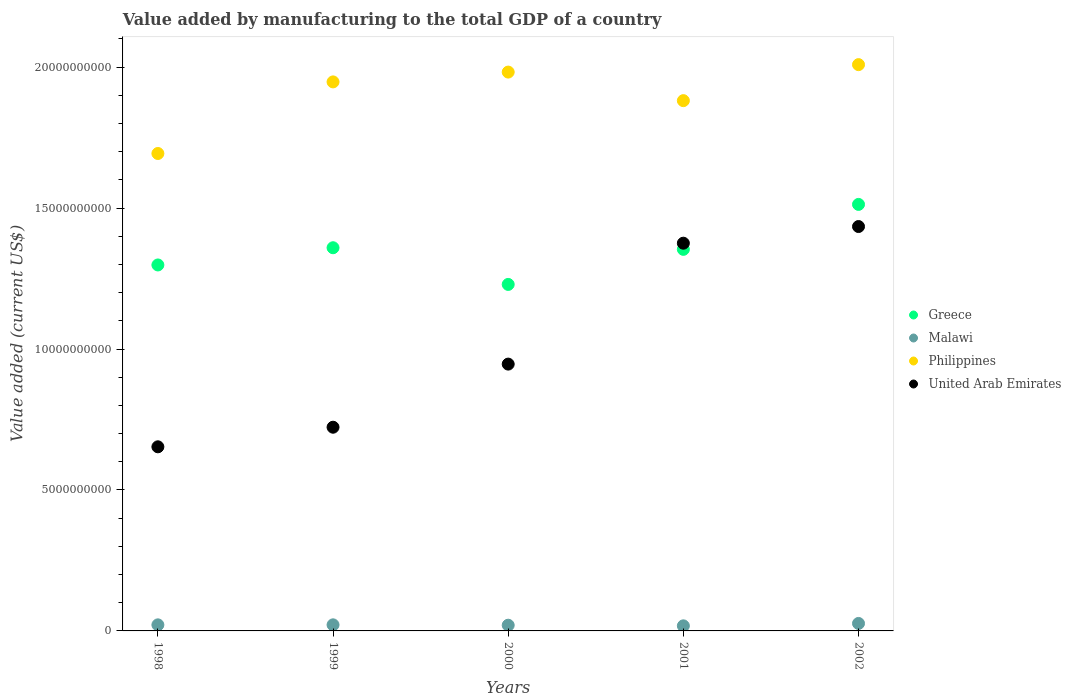How many different coloured dotlines are there?
Offer a terse response. 4. Is the number of dotlines equal to the number of legend labels?
Keep it short and to the point. Yes. What is the value added by manufacturing to the total GDP in United Arab Emirates in 1999?
Your answer should be compact. 7.23e+09. Across all years, what is the maximum value added by manufacturing to the total GDP in Malawi?
Your response must be concise. 2.65e+08. Across all years, what is the minimum value added by manufacturing to the total GDP in Greece?
Give a very brief answer. 1.23e+1. In which year was the value added by manufacturing to the total GDP in Philippines maximum?
Keep it short and to the point. 2002. What is the total value added by manufacturing to the total GDP in United Arab Emirates in the graph?
Offer a very short reply. 5.13e+1. What is the difference between the value added by manufacturing to the total GDP in Malawi in 2000 and that in 2002?
Keep it short and to the point. -6.27e+07. What is the difference between the value added by manufacturing to the total GDP in Philippines in 2002 and the value added by manufacturing to the total GDP in Malawi in 2001?
Offer a very short reply. 1.99e+1. What is the average value added by manufacturing to the total GDP in Malawi per year?
Your answer should be very brief. 2.16e+08. In the year 2001, what is the difference between the value added by manufacturing to the total GDP in United Arab Emirates and value added by manufacturing to the total GDP in Greece?
Give a very brief answer. 2.18e+08. In how many years, is the value added by manufacturing to the total GDP in United Arab Emirates greater than 14000000000 US$?
Provide a short and direct response. 1. What is the ratio of the value added by manufacturing to the total GDP in United Arab Emirates in 1998 to that in 1999?
Your response must be concise. 0.9. Is the value added by manufacturing to the total GDP in United Arab Emirates in 1999 less than that in 2001?
Your answer should be very brief. Yes. Is the difference between the value added by manufacturing to the total GDP in United Arab Emirates in 2001 and 2002 greater than the difference between the value added by manufacturing to the total GDP in Greece in 2001 and 2002?
Provide a short and direct response. Yes. What is the difference between the highest and the second highest value added by manufacturing to the total GDP in United Arab Emirates?
Ensure brevity in your answer.  5.91e+08. What is the difference between the highest and the lowest value added by manufacturing to the total GDP in Greece?
Keep it short and to the point. 2.84e+09. Is the sum of the value added by manufacturing to the total GDP in Greece in 1998 and 1999 greater than the maximum value added by manufacturing to the total GDP in United Arab Emirates across all years?
Ensure brevity in your answer.  Yes. Is it the case that in every year, the sum of the value added by manufacturing to the total GDP in Philippines and value added by manufacturing to the total GDP in United Arab Emirates  is greater than the sum of value added by manufacturing to the total GDP in Greece and value added by manufacturing to the total GDP in Malawi?
Provide a succinct answer. No. Is it the case that in every year, the sum of the value added by manufacturing to the total GDP in United Arab Emirates and value added by manufacturing to the total GDP in Malawi  is greater than the value added by manufacturing to the total GDP in Greece?
Provide a short and direct response. No. Is the value added by manufacturing to the total GDP in Malawi strictly greater than the value added by manufacturing to the total GDP in Philippines over the years?
Ensure brevity in your answer.  No. Is the value added by manufacturing to the total GDP in Greece strictly less than the value added by manufacturing to the total GDP in United Arab Emirates over the years?
Provide a succinct answer. No. How many years are there in the graph?
Offer a terse response. 5. Are the values on the major ticks of Y-axis written in scientific E-notation?
Provide a succinct answer. No. Does the graph contain any zero values?
Your answer should be very brief. No. Where does the legend appear in the graph?
Your response must be concise. Center right. How many legend labels are there?
Your response must be concise. 4. How are the legend labels stacked?
Your answer should be compact. Vertical. What is the title of the graph?
Ensure brevity in your answer.  Value added by manufacturing to the total GDP of a country. Does "Tuvalu" appear as one of the legend labels in the graph?
Offer a very short reply. No. What is the label or title of the Y-axis?
Provide a succinct answer. Value added (current US$). What is the Value added (current US$) in Greece in 1998?
Offer a very short reply. 1.30e+1. What is the Value added (current US$) of Malawi in 1998?
Make the answer very short. 2.16e+08. What is the Value added (current US$) in Philippines in 1998?
Keep it short and to the point. 1.69e+1. What is the Value added (current US$) in United Arab Emirates in 1998?
Offer a very short reply. 6.53e+09. What is the Value added (current US$) of Greece in 1999?
Your answer should be compact. 1.36e+1. What is the Value added (current US$) of Malawi in 1999?
Your answer should be compact. 2.16e+08. What is the Value added (current US$) in Philippines in 1999?
Your answer should be very brief. 1.95e+1. What is the Value added (current US$) of United Arab Emirates in 1999?
Provide a short and direct response. 7.23e+09. What is the Value added (current US$) in Greece in 2000?
Make the answer very short. 1.23e+1. What is the Value added (current US$) of Malawi in 2000?
Ensure brevity in your answer.  2.03e+08. What is the Value added (current US$) in Philippines in 2000?
Ensure brevity in your answer.  1.98e+1. What is the Value added (current US$) of United Arab Emirates in 2000?
Your answer should be very brief. 9.47e+09. What is the Value added (current US$) of Greece in 2001?
Provide a short and direct response. 1.35e+1. What is the Value added (current US$) of Malawi in 2001?
Offer a terse response. 1.80e+08. What is the Value added (current US$) in Philippines in 2001?
Keep it short and to the point. 1.88e+1. What is the Value added (current US$) in United Arab Emirates in 2001?
Your response must be concise. 1.38e+1. What is the Value added (current US$) of Greece in 2002?
Keep it short and to the point. 1.51e+1. What is the Value added (current US$) in Malawi in 2002?
Your answer should be compact. 2.65e+08. What is the Value added (current US$) of Philippines in 2002?
Give a very brief answer. 2.01e+1. What is the Value added (current US$) of United Arab Emirates in 2002?
Your answer should be compact. 1.43e+1. Across all years, what is the maximum Value added (current US$) of Greece?
Give a very brief answer. 1.51e+1. Across all years, what is the maximum Value added (current US$) of Malawi?
Keep it short and to the point. 2.65e+08. Across all years, what is the maximum Value added (current US$) in Philippines?
Give a very brief answer. 2.01e+1. Across all years, what is the maximum Value added (current US$) of United Arab Emirates?
Your answer should be compact. 1.43e+1. Across all years, what is the minimum Value added (current US$) in Greece?
Your answer should be compact. 1.23e+1. Across all years, what is the minimum Value added (current US$) in Malawi?
Your answer should be very brief. 1.80e+08. Across all years, what is the minimum Value added (current US$) of Philippines?
Provide a succinct answer. 1.69e+1. Across all years, what is the minimum Value added (current US$) of United Arab Emirates?
Give a very brief answer. 6.53e+09. What is the total Value added (current US$) of Greece in the graph?
Give a very brief answer. 6.75e+1. What is the total Value added (current US$) of Malawi in the graph?
Offer a very short reply. 1.08e+09. What is the total Value added (current US$) in Philippines in the graph?
Give a very brief answer. 9.51e+1. What is the total Value added (current US$) of United Arab Emirates in the graph?
Your answer should be very brief. 5.13e+1. What is the difference between the Value added (current US$) in Greece in 1998 and that in 1999?
Make the answer very short. -6.11e+08. What is the difference between the Value added (current US$) of Malawi in 1998 and that in 1999?
Your response must be concise. -5.31e+05. What is the difference between the Value added (current US$) in Philippines in 1998 and that in 1999?
Provide a short and direct response. -2.54e+09. What is the difference between the Value added (current US$) in United Arab Emirates in 1998 and that in 1999?
Provide a succinct answer. -6.95e+08. What is the difference between the Value added (current US$) in Greece in 1998 and that in 2000?
Provide a short and direct response. 6.91e+08. What is the difference between the Value added (current US$) in Malawi in 1998 and that in 2000?
Provide a short and direct response. 1.30e+07. What is the difference between the Value added (current US$) of Philippines in 1998 and that in 2000?
Your response must be concise. -2.89e+09. What is the difference between the Value added (current US$) of United Arab Emirates in 1998 and that in 2000?
Offer a very short reply. -2.93e+09. What is the difference between the Value added (current US$) in Greece in 1998 and that in 2001?
Make the answer very short. -5.54e+08. What is the difference between the Value added (current US$) of Malawi in 1998 and that in 2001?
Offer a very short reply. 3.54e+07. What is the difference between the Value added (current US$) in Philippines in 1998 and that in 2001?
Your answer should be very brief. -1.87e+09. What is the difference between the Value added (current US$) in United Arab Emirates in 1998 and that in 2001?
Keep it short and to the point. -7.22e+09. What is the difference between the Value added (current US$) of Greece in 1998 and that in 2002?
Keep it short and to the point. -2.15e+09. What is the difference between the Value added (current US$) in Malawi in 1998 and that in 2002?
Your answer should be compact. -4.97e+07. What is the difference between the Value added (current US$) in Philippines in 1998 and that in 2002?
Your response must be concise. -3.15e+09. What is the difference between the Value added (current US$) of United Arab Emirates in 1998 and that in 2002?
Make the answer very short. -7.81e+09. What is the difference between the Value added (current US$) in Greece in 1999 and that in 2000?
Your response must be concise. 1.30e+09. What is the difference between the Value added (current US$) of Malawi in 1999 and that in 2000?
Keep it short and to the point. 1.35e+07. What is the difference between the Value added (current US$) of Philippines in 1999 and that in 2000?
Provide a succinct answer. -3.48e+08. What is the difference between the Value added (current US$) in United Arab Emirates in 1999 and that in 2000?
Your response must be concise. -2.24e+09. What is the difference between the Value added (current US$) in Greece in 1999 and that in 2001?
Ensure brevity in your answer.  5.73e+07. What is the difference between the Value added (current US$) in Malawi in 1999 and that in 2001?
Your answer should be very brief. 3.59e+07. What is the difference between the Value added (current US$) of Philippines in 1999 and that in 2001?
Provide a short and direct response. 6.65e+08. What is the difference between the Value added (current US$) in United Arab Emirates in 1999 and that in 2001?
Your answer should be very brief. -6.53e+09. What is the difference between the Value added (current US$) in Greece in 1999 and that in 2002?
Your response must be concise. -1.54e+09. What is the difference between the Value added (current US$) of Malawi in 1999 and that in 2002?
Ensure brevity in your answer.  -4.92e+07. What is the difference between the Value added (current US$) in Philippines in 1999 and that in 2002?
Offer a terse response. -6.12e+08. What is the difference between the Value added (current US$) of United Arab Emirates in 1999 and that in 2002?
Offer a terse response. -7.12e+09. What is the difference between the Value added (current US$) in Greece in 2000 and that in 2001?
Offer a very short reply. -1.24e+09. What is the difference between the Value added (current US$) in Malawi in 2000 and that in 2001?
Offer a very short reply. 2.24e+07. What is the difference between the Value added (current US$) of Philippines in 2000 and that in 2001?
Provide a short and direct response. 1.01e+09. What is the difference between the Value added (current US$) in United Arab Emirates in 2000 and that in 2001?
Offer a very short reply. -4.29e+09. What is the difference between the Value added (current US$) in Greece in 2000 and that in 2002?
Provide a succinct answer. -2.84e+09. What is the difference between the Value added (current US$) in Malawi in 2000 and that in 2002?
Give a very brief answer. -6.27e+07. What is the difference between the Value added (current US$) in Philippines in 2000 and that in 2002?
Ensure brevity in your answer.  -2.64e+08. What is the difference between the Value added (current US$) in United Arab Emirates in 2000 and that in 2002?
Provide a short and direct response. -4.88e+09. What is the difference between the Value added (current US$) of Greece in 2001 and that in 2002?
Offer a terse response. -1.59e+09. What is the difference between the Value added (current US$) in Malawi in 2001 and that in 2002?
Provide a short and direct response. -8.51e+07. What is the difference between the Value added (current US$) of Philippines in 2001 and that in 2002?
Keep it short and to the point. -1.28e+09. What is the difference between the Value added (current US$) in United Arab Emirates in 2001 and that in 2002?
Give a very brief answer. -5.91e+08. What is the difference between the Value added (current US$) of Greece in 1998 and the Value added (current US$) of Malawi in 1999?
Your response must be concise. 1.28e+1. What is the difference between the Value added (current US$) of Greece in 1998 and the Value added (current US$) of Philippines in 1999?
Offer a very short reply. -6.49e+09. What is the difference between the Value added (current US$) in Greece in 1998 and the Value added (current US$) in United Arab Emirates in 1999?
Keep it short and to the point. 5.76e+09. What is the difference between the Value added (current US$) of Malawi in 1998 and the Value added (current US$) of Philippines in 1999?
Make the answer very short. -1.93e+1. What is the difference between the Value added (current US$) in Malawi in 1998 and the Value added (current US$) in United Arab Emirates in 1999?
Your response must be concise. -7.01e+09. What is the difference between the Value added (current US$) in Philippines in 1998 and the Value added (current US$) in United Arab Emirates in 1999?
Offer a very short reply. 9.71e+09. What is the difference between the Value added (current US$) in Greece in 1998 and the Value added (current US$) in Malawi in 2000?
Provide a short and direct response. 1.28e+1. What is the difference between the Value added (current US$) in Greece in 1998 and the Value added (current US$) in Philippines in 2000?
Keep it short and to the point. -6.84e+09. What is the difference between the Value added (current US$) of Greece in 1998 and the Value added (current US$) of United Arab Emirates in 2000?
Keep it short and to the point. 3.52e+09. What is the difference between the Value added (current US$) of Malawi in 1998 and the Value added (current US$) of Philippines in 2000?
Offer a terse response. -1.96e+1. What is the difference between the Value added (current US$) in Malawi in 1998 and the Value added (current US$) in United Arab Emirates in 2000?
Your answer should be compact. -9.25e+09. What is the difference between the Value added (current US$) of Philippines in 1998 and the Value added (current US$) of United Arab Emirates in 2000?
Ensure brevity in your answer.  7.47e+09. What is the difference between the Value added (current US$) of Greece in 1998 and the Value added (current US$) of Malawi in 2001?
Provide a succinct answer. 1.28e+1. What is the difference between the Value added (current US$) in Greece in 1998 and the Value added (current US$) in Philippines in 2001?
Provide a short and direct response. -5.83e+09. What is the difference between the Value added (current US$) of Greece in 1998 and the Value added (current US$) of United Arab Emirates in 2001?
Offer a very short reply. -7.72e+08. What is the difference between the Value added (current US$) in Malawi in 1998 and the Value added (current US$) in Philippines in 2001?
Keep it short and to the point. -1.86e+1. What is the difference between the Value added (current US$) in Malawi in 1998 and the Value added (current US$) in United Arab Emirates in 2001?
Offer a terse response. -1.35e+1. What is the difference between the Value added (current US$) of Philippines in 1998 and the Value added (current US$) of United Arab Emirates in 2001?
Your response must be concise. 3.18e+09. What is the difference between the Value added (current US$) of Greece in 1998 and the Value added (current US$) of Malawi in 2002?
Give a very brief answer. 1.27e+1. What is the difference between the Value added (current US$) of Greece in 1998 and the Value added (current US$) of Philippines in 2002?
Provide a succinct answer. -7.11e+09. What is the difference between the Value added (current US$) in Greece in 1998 and the Value added (current US$) in United Arab Emirates in 2002?
Your response must be concise. -1.36e+09. What is the difference between the Value added (current US$) in Malawi in 1998 and the Value added (current US$) in Philippines in 2002?
Provide a succinct answer. -1.99e+1. What is the difference between the Value added (current US$) of Malawi in 1998 and the Value added (current US$) of United Arab Emirates in 2002?
Your response must be concise. -1.41e+1. What is the difference between the Value added (current US$) of Philippines in 1998 and the Value added (current US$) of United Arab Emirates in 2002?
Keep it short and to the point. 2.59e+09. What is the difference between the Value added (current US$) of Greece in 1999 and the Value added (current US$) of Malawi in 2000?
Provide a short and direct response. 1.34e+1. What is the difference between the Value added (current US$) in Greece in 1999 and the Value added (current US$) in Philippines in 2000?
Keep it short and to the point. -6.23e+09. What is the difference between the Value added (current US$) of Greece in 1999 and the Value added (current US$) of United Arab Emirates in 2000?
Make the answer very short. 4.13e+09. What is the difference between the Value added (current US$) in Malawi in 1999 and the Value added (current US$) in Philippines in 2000?
Your response must be concise. -1.96e+1. What is the difference between the Value added (current US$) in Malawi in 1999 and the Value added (current US$) in United Arab Emirates in 2000?
Provide a succinct answer. -9.25e+09. What is the difference between the Value added (current US$) of Philippines in 1999 and the Value added (current US$) of United Arab Emirates in 2000?
Your answer should be very brief. 1.00e+1. What is the difference between the Value added (current US$) of Greece in 1999 and the Value added (current US$) of Malawi in 2001?
Ensure brevity in your answer.  1.34e+1. What is the difference between the Value added (current US$) of Greece in 1999 and the Value added (current US$) of Philippines in 2001?
Provide a succinct answer. -5.22e+09. What is the difference between the Value added (current US$) of Greece in 1999 and the Value added (current US$) of United Arab Emirates in 2001?
Offer a terse response. -1.61e+08. What is the difference between the Value added (current US$) in Malawi in 1999 and the Value added (current US$) in Philippines in 2001?
Provide a short and direct response. -1.86e+1. What is the difference between the Value added (current US$) of Malawi in 1999 and the Value added (current US$) of United Arab Emirates in 2001?
Keep it short and to the point. -1.35e+1. What is the difference between the Value added (current US$) in Philippines in 1999 and the Value added (current US$) in United Arab Emirates in 2001?
Your response must be concise. 5.72e+09. What is the difference between the Value added (current US$) of Greece in 1999 and the Value added (current US$) of Malawi in 2002?
Your answer should be compact. 1.33e+1. What is the difference between the Value added (current US$) of Greece in 1999 and the Value added (current US$) of Philippines in 2002?
Provide a short and direct response. -6.50e+09. What is the difference between the Value added (current US$) in Greece in 1999 and the Value added (current US$) in United Arab Emirates in 2002?
Your answer should be compact. -7.52e+08. What is the difference between the Value added (current US$) of Malawi in 1999 and the Value added (current US$) of Philippines in 2002?
Offer a very short reply. -1.99e+1. What is the difference between the Value added (current US$) of Malawi in 1999 and the Value added (current US$) of United Arab Emirates in 2002?
Keep it short and to the point. -1.41e+1. What is the difference between the Value added (current US$) in Philippines in 1999 and the Value added (current US$) in United Arab Emirates in 2002?
Make the answer very short. 5.13e+09. What is the difference between the Value added (current US$) in Greece in 2000 and the Value added (current US$) in Malawi in 2001?
Make the answer very short. 1.21e+1. What is the difference between the Value added (current US$) in Greece in 2000 and the Value added (current US$) in Philippines in 2001?
Make the answer very short. -6.52e+09. What is the difference between the Value added (current US$) in Greece in 2000 and the Value added (current US$) in United Arab Emirates in 2001?
Your answer should be very brief. -1.46e+09. What is the difference between the Value added (current US$) in Malawi in 2000 and the Value added (current US$) in Philippines in 2001?
Your answer should be very brief. -1.86e+1. What is the difference between the Value added (current US$) of Malawi in 2000 and the Value added (current US$) of United Arab Emirates in 2001?
Ensure brevity in your answer.  -1.36e+1. What is the difference between the Value added (current US$) of Philippines in 2000 and the Value added (current US$) of United Arab Emirates in 2001?
Your answer should be very brief. 6.07e+09. What is the difference between the Value added (current US$) in Greece in 2000 and the Value added (current US$) in Malawi in 2002?
Offer a very short reply. 1.20e+1. What is the difference between the Value added (current US$) in Greece in 2000 and the Value added (current US$) in Philippines in 2002?
Provide a short and direct response. -7.80e+09. What is the difference between the Value added (current US$) in Greece in 2000 and the Value added (current US$) in United Arab Emirates in 2002?
Provide a succinct answer. -2.05e+09. What is the difference between the Value added (current US$) of Malawi in 2000 and the Value added (current US$) of Philippines in 2002?
Keep it short and to the point. -1.99e+1. What is the difference between the Value added (current US$) in Malawi in 2000 and the Value added (current US$) in United Arab Emirates in 2002?
Offer a terse response. -1.41e+1. What is the difference between the Value added (current US$) in Philippines in 2000 and the Value added (current US$) in United Arab Emirates in 2002?
Give a very brief answer. 5.48e+09. What is the difference between the Value added (current US$) in Greece in 2001 and the Value added (current US$) in Malawi in 2002?
Your response must be concise. 1.33e+1. What is the difference between the Value added (current US$) in Greece in 2001 and the Value added (current US$) in Philippines in 2002?
Provide a short and direct response. -6.55e+09. What is the difference between the Value added (current US$) in Greece in 2001 and the Value added (current US$) in United Arab Emirates in 2002?
Keep it short and to the point. -8.10e+08. What is the difference between the Value added (current US$) of Malawi in 2001 and the Value added (current US$) of Philippines in 2002?
Make the answer very short. -1.99e+1. What is the difference between the Value added (current US$) in Malawi in 2001 and the Value added (current US$) in United Arab Emirates in 2002?
Offer a very short reply. -1.42e+1. What is the difference between the Value added (current US$) in Philippines in 2001 and the Value added (current US$) in United Arab Emirates in 2002?
Offer a very short reply. 4.47e+09. What is the average Value added (current US$) in Greece per year?
Provide a short and direct response. 1.35e+1. What is the average Value added (current US$) in Malawi per year?
Offer a very short reply. 2.16e+08. What is the average Value added (current US$) of Philippines per year?
Your answer should be compact. 1.90e+1. What is the average Value added (current US$) in United Arab Emirates per year?
Your answer should be compact. 1.03e+1. In the year 1998, what is the difference between the Value added (current US$) in Greece and Value added (current US$) in Malawi?
Your answer should be very brief. 1.28e+1. In the year 1998, what is the difference between the Value added (current US$) in Greece and Value added (current US$) in Philippines?
Your response must be concise. -3.95e+09. In the year 1998, what is the difference between the Value added (current US$) of Greece and Value added (current US$) of United Arab Emirates?
Your response must be concise. 6.45e+09. In the year 1998, what is the difference between the Value added (current US$) of Malawi and Value added (current US$) of Philippines?
Offer a terse response. -1.67e+1. In the year 1998, what is the difference between the Value added (current US$) in Malawi and Value added (current US$) in United Arab Emirates?
Offer a terse response. -6.32e+09. In the year 1998, what is the difference between the Value added (current US$) of Philippines and Value added (current US$) of United Arab Emirates?
Your answer should be very brief. 1.04e+1. In the year 1999, what is the difference between the Value added (current US$) in Greece and Value added (current US$) in Malawi?
Provide a short and direct response. 1.34e+1. In the year 1999, what is the difference between the Value added (current US$) in Greece and Value added (current US$) in Philippines?
Keep it short and to the point. -5.88e+09. In the year 1999, what is the difference between the Value added (current US$) of Greece and Value added (current US$) of United Arab Emirates?
Provide a succinct answer. 6.37e+09. In the year 1999, what is the difference between the Value added (current US$) in Malawi and Value added (current US$) in Philippines?
Keep it short and to the point. -1.93e+1. In the year 1999, what is the difference between the Value added (current US$) of Malawi and Value added (current US$) of United Arab Emirates?
Make the answer very short. -7.01e+09. In the year 1999, what is the difference between the Value added (current US$) of Philippines and Value added (current US$) of United Arab Emirates?
Make the answer very short. 1.23e+1. In the year 2000, what is the difference between the Value added (current US$) in Greece and Value added (current US$) in Malawi?
Your answer should be compact. 1.21e+1. In the year 2000, what is the difference between the Value added (current US$) of Greece and Value added (current US$) of Philippines?
Offer a terse response. -7.53e+09. In the year 2000, what is the difference between the Value added (current US$) in Greece and Value added (current US$) in United Arab Emirates?
Your response must be concise. 2.83e+09. In the year 2000, what is the difference between the Value added (current US$) of Malawi and Value added (current US$) of Philippines?
Provide a succinct answer. -1.96e+1. In the year 2000, what is the difference between the Value added (current US$) of Malawi and Value added (current US$) of United Arab Emirates?
Offer a very short reply. -9.26e+09. In the year 2000, what is the difference between the Value added (current US$) in Philippines and Value added (current US$) in United Arab Emirates?
Provide a short and direct response. 1.04e+1. In the year 2001, what is the difference between the Value added (current US$) of Greece and Value added (current US$) of Malawi?
Provide a short and direct response. 1.34e+1. In the year 2001, what is the difference between the Value added (current US$) in Greece and Value added (current US$) in Philippines?
Offer a terse response. -5.28e+09. In the year 2001, what is the difference between the Value added (current US$) of Greece and Value added (current US$) of United Arab Emirates?
Ensure brevity in your answer.  -2.18e+08. In the year 2001, what is the difference between the Value added (current US$) of Malawi and Value added (current US$) of Philippines?
Make the answer very short. -1.86e+1. In the year 2001, what is the difference between the Value added (current US$) in Malawi and Value added (current US$) in United Arab Emirates?
Ensure brevity in your answer.  -1.36e+1. In the year 2001, what is the difference between the Value added (current US$) in Philippines and Value added (current US$) in United Arab Emirates?
Provide a short and direct response. 5.06e+09. In the year 2002, what is the difference between the Value added (current US$) of Greece and Value added (current US$) of Malawi?
Make the answer very short. 1.49e+1. In the year 2002, what is the difference between the Value added (current US$) in Greece and Value added (current US$) in Philippines?
Your answer should be very brief. -4.96e+09. In the year 2002, what is the difference between the Value added (current US$) of Greece and Value added (current US$) of United Arab Emirates?
Your response must be concise. 7.85e+08. In the year 2002, what is the difference between the Value added (current US$) in Malawi and Value added (current US$) in Philippines?
Make the answer very short. -1.98e+1. In the year 2002, what is the difference between the Value added (current US$) in Malawi and Value added (current US$) in United Arab Emirates?
Your response must be concise. -1.41e+1. In the year 2002, what is the difference between the Value added (current US$) in Philippines and Value added (current US$) in United Arab Emirates?
Your response must be concise. 5.74e+09. What is the ratio of the Value added (current US$) of Greece in 1998 to that in 1999?
Your response must be concise. 0.96. What is the ratio of the Value added (current US$) in Philippines in 1998 to that in 1999?
Offer a very short reply. 0.87. What is the ratio of the Value added (current US$) of United Arab Emirates in 1998 to that in 1999?
Your answer should be compact. 0.9. What is the ratio of the Value added (current US$) in Greece in 1998 to that in 2000?
Give a very brief answer. 1.06. What is the ratio of the Value added (current US$) of Malawi in 1998 to that in 2000?
Give a very brief answer. 1.06. What is the ratio of the Value added (current US$) of Philippines in 1998 to that in 2000?
Make the answer very short. 0.85. What is the ratio of the Value added (current US$) of United Arab Emirates in 1998 to that in 2000?
Ensure brevity in your answer.  0.69. What is the ratio of the Value added (current US$) in Greece in 1998 to that in 2001?
Your answer should be very brief. 0.96. What is the ratio of the Value added (current US$) in Malawi in 1998 to that in 2001?
Offer a terse response. 1.2. What is the ratio of the Value added (current US$) of Philippines in 1998 to that in 2001?
Your answer should be very brief. 0.9. What is the ratio of the Value added (current US$) in United Arab Emirates in 1998 to that in 2001?
Your answer should be very brief. 0.47. What is the ratio of the Value added (current US$) of Greece in 1998 to that in 2002?
Provide a succinct answer. 0.86. What is the ratio of the Value added (current US$) of Malawi in 1998 to that in 2002?
Your answer should be very brief. 0.81. What is the ratio of the Value added (current US$) in Philippines in 1998 to that in 2002?
Offer a terse response. 0.84. What is the ratio of the Value added (current US$) in United Arab Emirates in 1998 to that in 2002?
Your answer should be compact. 0.46. What is the ratio of the Value added (current US$) in Greece in 1999 to that in 2000?
Provide a short and direct response. 1.11. What is the ratio of the Value added (current US$) of Malawi in 1999 to that in 2000?
Provide a short and direct response. 1.07. What is the ratio of the Value added (current US$) of Philippines in 1999 to that in 2000?
Ensure brevity in your answer.  0.98. What is the ratio of the Value added (current US$) in United Arab Emirates in 1999 to that in 2000?
Offer a very short reply. 0.76. What is the ratio of the Value added (current US$) of Malawi in 1999 to that in 2001?
Ensure brevity in your answer.  1.2. What is the ratio of the Value added (current US$) in Philippines in 1999 to that in 2001?
Provide a short and direct response. 1.04. What is the ratio of the Value added (current US$) of United Arab Emirates in 1999 to that in 2001?
Keep it short and to the point. 0.53. What is the ratio of the Value added (current US$) in Greece in 1999 to that in 2002?
Your answer should be very brief. 0.9. What is the ratio of the Value added (current US$) in Malawi in 1999 to that in 2002?
Make the answer very short. 0.81. What is the ratio of the Value added (current US$) of Philippines in 1999 to that in 2002?
Your response must be concise. 0.97. What is the ratio of the Value added (current US$) in United Arab Emirates in 1999 to that in 2002?
Keep it short and to the point. 0.5. What is the ratio of the Value added (current US$) of Greece in 2000 to that in 2001?
Your answer should be compact. 0.91. What is the ratio of the Value added (current US$) in Malawi in 2000 to that in 2001?
Offer a terse response. 1.12. What is the ratio of the Value added (current US$) of Philippines in 2000 to that in 2001?
Your answer should be compact. 1.05. What is the ratio of the Value added (current US$) in United Arab Emirates in 2000 to that in 2001?
Make the answer very short. 0.69. What is the ratio of the Value added (current US$) of Greece in 2000 to that in 2002?
Your answer should be very brief. 0.81. What is the ratio of the Value added (current US$) of Malawi in 2000 to that in 2002?
Keep it short and to the point. 0.76. What is the ratio of the Value added (current US$) of Philippines in 2000 to that in 2002?
Your response must be concise. 0.99. What is the ratio of the Value added (current US$) in United Arab Emirates in 2000 to that in 2002?
Make the answer very short. 0.66. What is the ratio of the Value added (current US$) of Greece in 2001 to that in 2002?
Your answer should be very brief. 0.89. What is the ratio of the Value added (current US$) of Malawi in 2001 to that in 2002?
Keep it short and to the point. 0.68. What is the ratio of the Value added (current US$) in Philippines in 2001 to that in 2002?
Your answer should be very brief. 0.94. What is the ratio of the Value added (current US$) in United Arab Emirates in 2001 to that in 2002?
Your answer should be very brief. 0.96. What is the difference between the highest and the second highest Value added (current US$) in Greece?
Your response must be concise. 1.54e+09. What is the difference between the highest and the second highest Value added (current US$) in Malawi?
Offer a terse response. 4.92e+07. What is the difference between the highest and the second highest Value added (current US$) of Philippines?
Give a very brief answer. 2.64e+08. What is the difference between the highest and the second highest Value added (current US$) of United Arab Emirates?
Provide a succinct answer. 5.91e+08. What is the difference between the highest and the lowest Value added (current US$) of Greece?
Your response must be concise. 2.84e+09. What is the difference between the highest and the lowest Value added (current US$) of Malawi?
Offer a very short reply. 8.51e+07. What is the difference between the highest and the lowest Value added (current US$) in Philippines?
Ensure brevity in your answer.  3.15e+09. What is the difference between the highest and the lowest Value added (current US$) of United Arab Emirates?
Your answer should be very brief. 7.81e+09. 